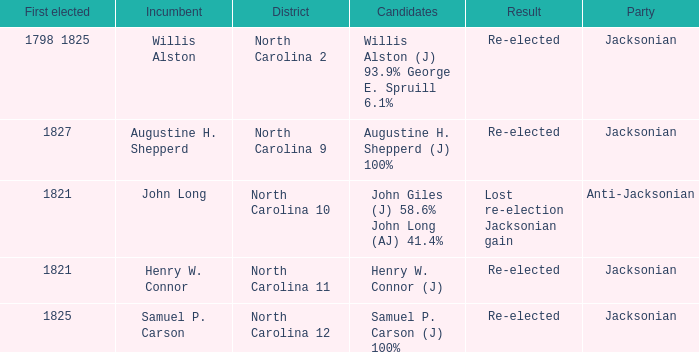Name the result for  augustine h. shepperd (j) 100% Re-elected. 